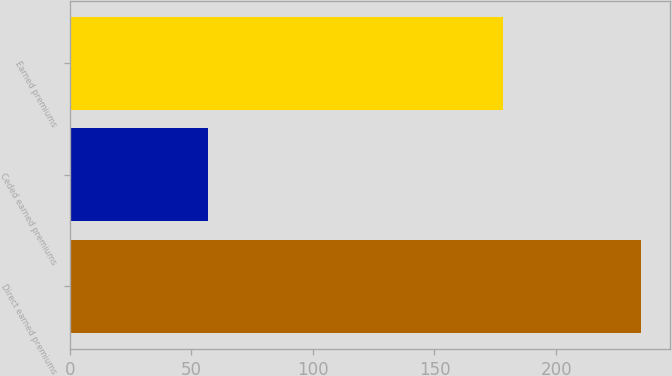Convert chart. <chart><loc_0><loc_0><loc_500><loc_500><bar_chart><fcel>Direct earned premiums<fcel>Ceded earned premiums<fcel>Earned premiums<nl><fcel>235<fcel>57<fcel>178<nl></chart> 